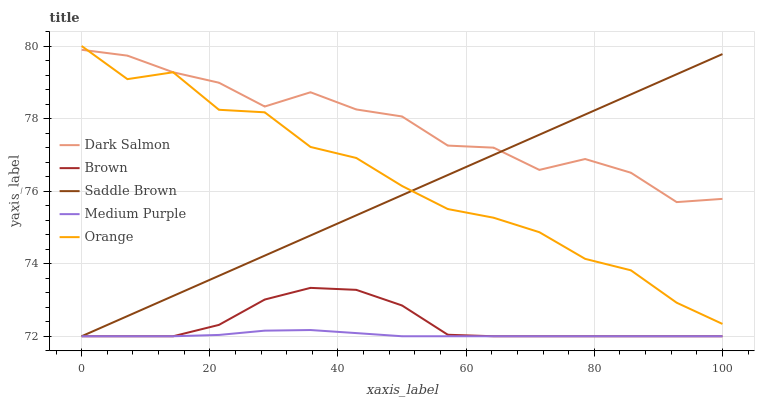Does Medium Purple have the minimum area under the curve?
Answer yes or no. Yes. Does Dark Salmon have the maximum area under the curve?
Answer yes or no. Yes. Does Brown have the minimum area under the curve?
Answer yes or no. No. Does Brown have the maximum area under the curve?
Answer yes or no. No. Is Saddle Brown the smoothest?
Answer yes or no. Yes. Is Dark Salmon the roughest?
Answer yes or no. Yes. Is Brown the smoothest?
Answer yes or no. No. Is Brown the roughest?
Answer yes or no. No. Does Orange have the lowest value?
Answer yes or no. No. Does Orange have the highest value?
Answer yes or no. Yes. Does Brown have the highest value?
Answer yes or no. No. Is Brown less than Orange?
Answer yes or no. Yes. Is Dark Salmon greater than Medium Purple?
Answer yes or no. Yes. Does Orange intersect Dark Salmon?
Answer yes or no. Yes. Is Orange less than Dark Salmon?
Answer yes or no. No. Is Orange greater than Dark Salmon?
Answer yes or no. No. Does Brown intersect Orange?
Answer yes or no. No. 